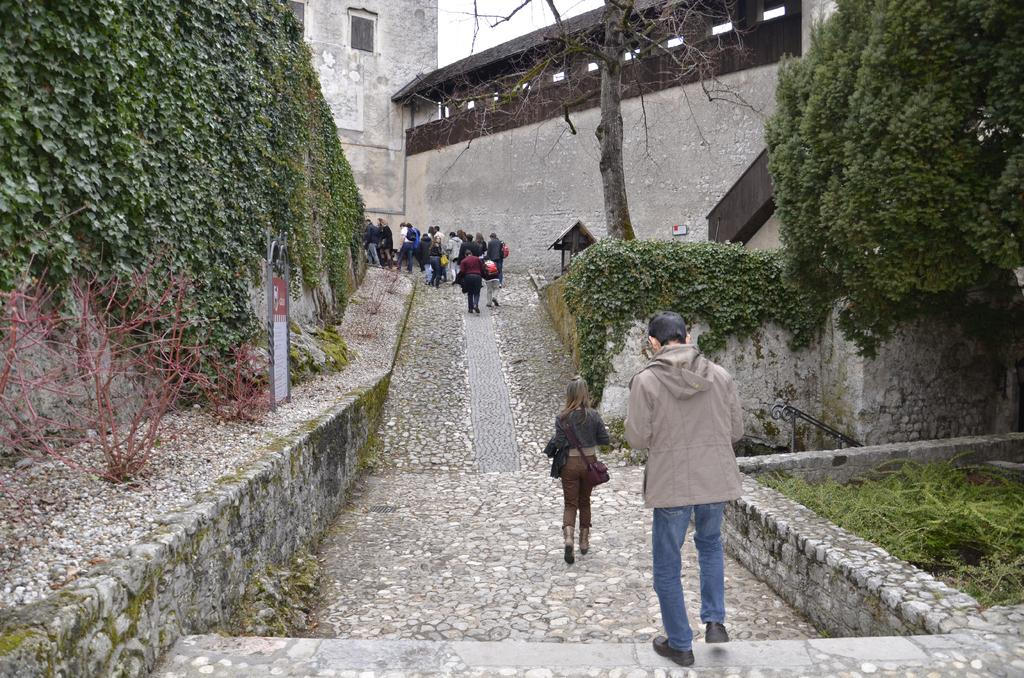What are the persons in the image doing? The persons in the image are walking on a walking path. What type of vegetation can be seen in the image? Creepers, trees, and plants are visible in the image. What structures are present in the image? There is a building and a shed in the image. What is visible in the sky in the image? The sky is visible in the image. What year is depicted in the picture? The image does not depict a specific year; it is a photograph of a scene with persons walking on a walking path, vegetation, and structures. 